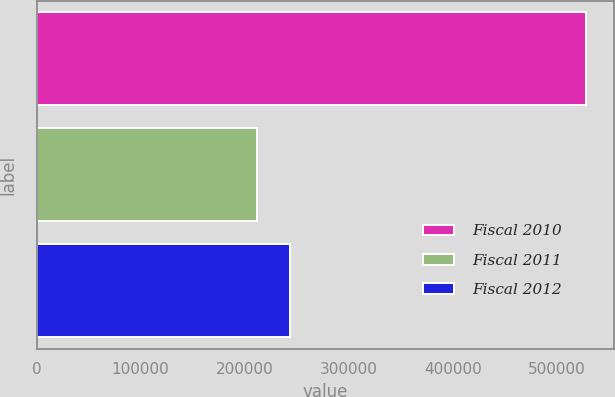Convert chart to OTSL. <chart><loc_0><loc_0><loc_500><loc_500><bar_chart><fcel>Fiscal 2010<fcel>Fiscal 2011<fcel>Fiscal 2012<nl><fcel>528000<fcel>212000<fcel>243600<nl></chart> 